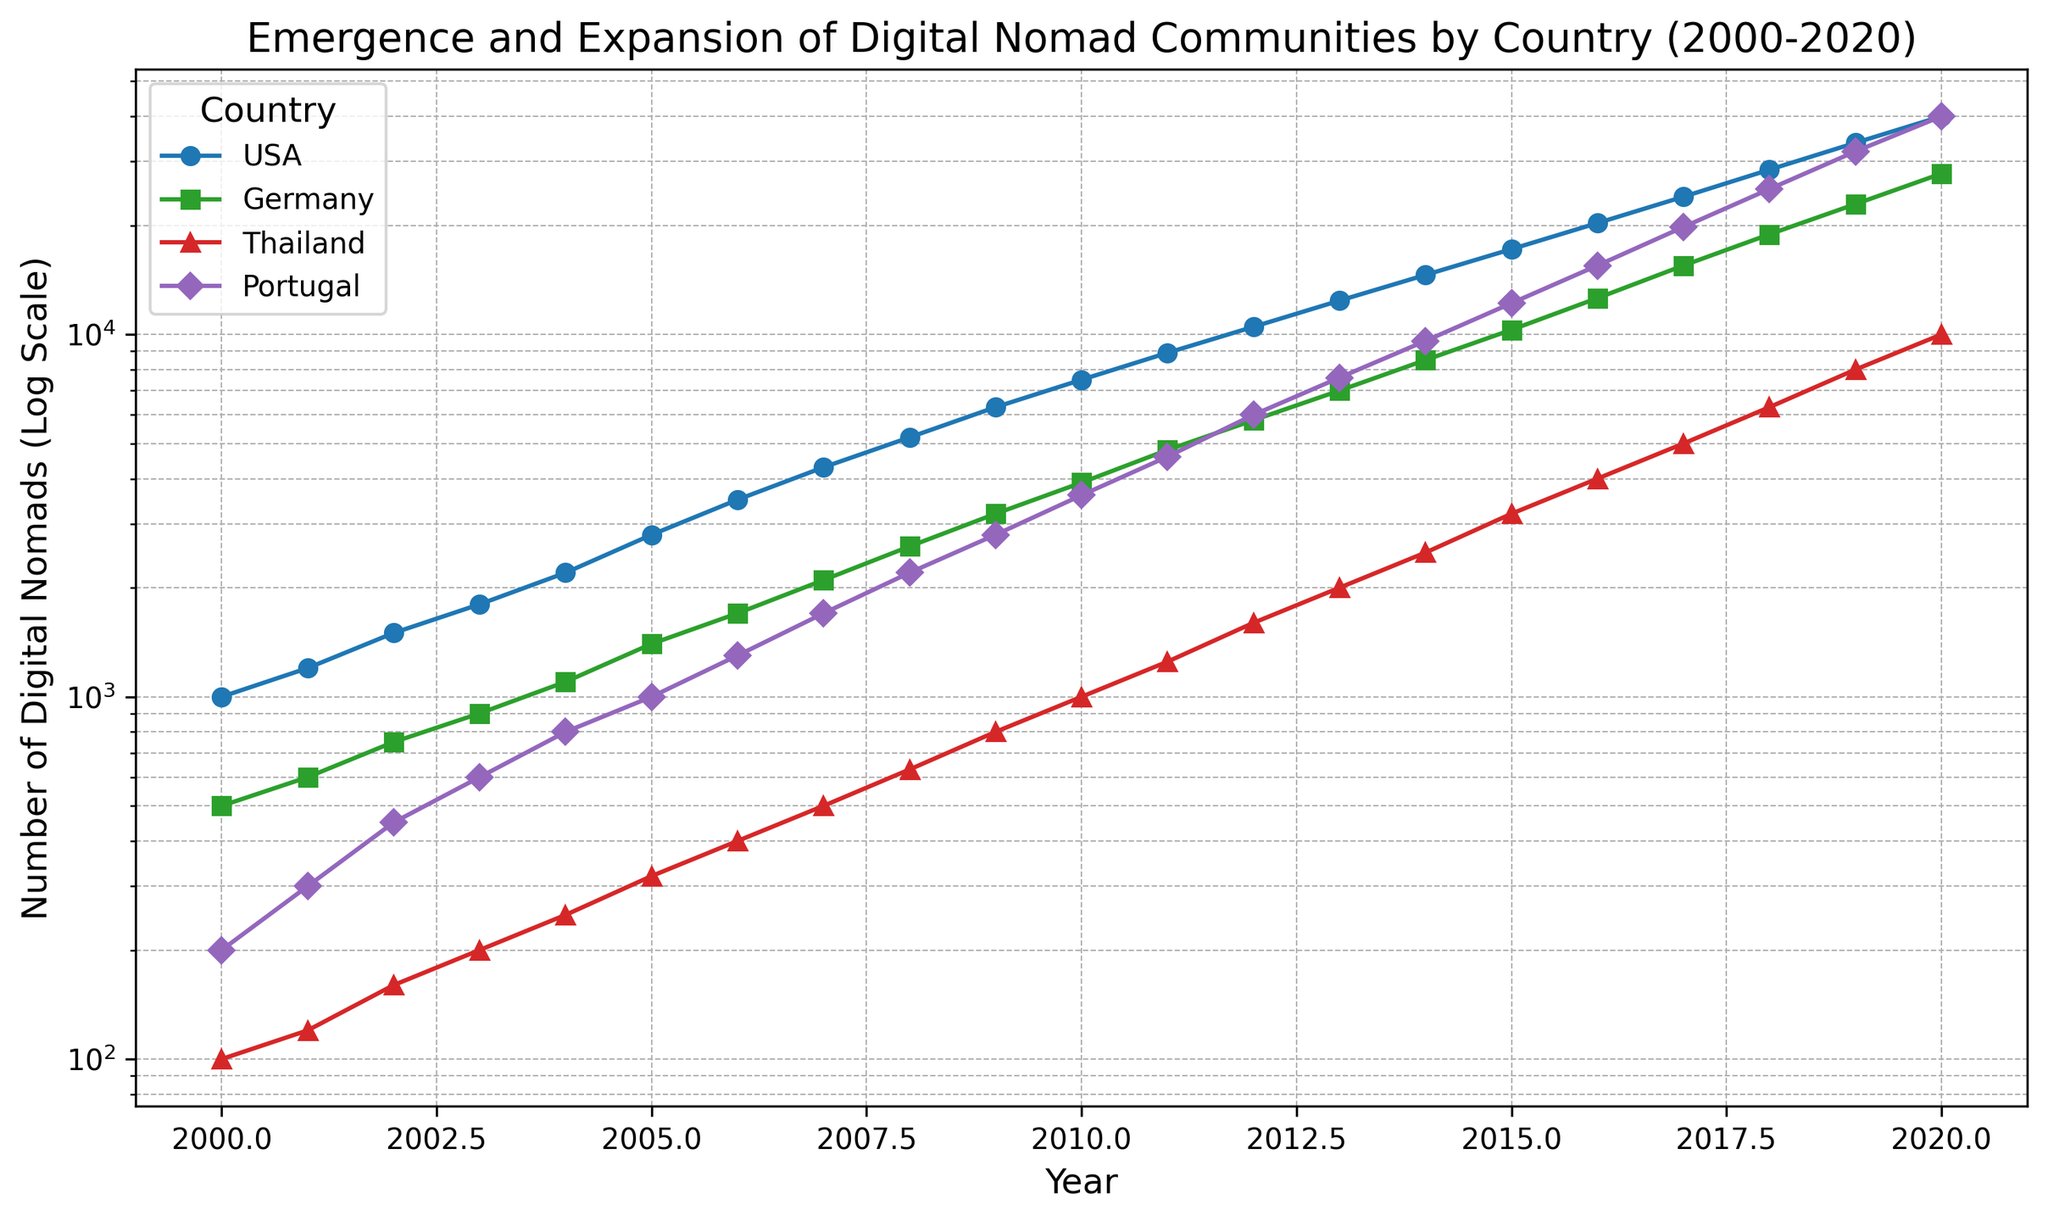Which country had the highest number of digital nomads in 2019? By looking at the 2019 data points for each country, USA has about 33,800, Thailand has 8,000, Germany has 22,900, and Portugal has 32,000. The USA's number is the highest.
Answer: USA What is the ratio of digital nomads in Thailand to those in Germany in 2010? Referring to the 2010 data points, Thailand has 1,000 and Germany has 3,900 digital nomads. The ratio is 1,000 divided by 3,900.
Answer: 1:3.9 Which country had the fastest growth in digital nomads from 2015 to 2020? By inspecting the slope of the lines between 2015 and 2020, Portugal's line shows the steepest increase, indicating the fastest growth compared to USA, Germany, and Thailand.
Answer: Portugal In which year did Germany surpass 10,000 digital nomads? Observing Germany's data points, it surpasses 10,000 in 2015.
Answer: 2015 How does the number of digital nomads in the USA in 2005 compare to that in Thailand in 2020? In 2005, the USA has about 2,800 digital nomads while Thailand in 2020 has about 10,000. Consequently, the number in Thailand in 2020 is significantly higher.
Answer: Thailand has more Which country showed a doubling in the number of digital nomads the quickest? Reviewing the data, Thailand doubles multiple times (e.g., from 1250 in 2011 to 2500 in 2014), which appears to be the quickest compared to other countries like USA, Germany, and Portugal.
Answer: Thailand If you sum the number of digital nomads in all the countries in 2020, what is the total? Summing the 2020 data points for USA (40,000), Germany (27,800), Thailand (10,000), and Portugal (40,000) gives 40,000 + 27,800 + 10,000 + 40,000.
Answer: 117,800 What is the trend in the number of digital nomads in Portugal from 2000 to 2020? Viewing the plotted data points for Portugal, the number steadily increases in an exponential manner from 2000 to 2020, reaching 40,000 in 2020.
Answer: Increasing exponentially Which country had the smallest number of digital nomads in 2008? Looking at the 2008 data points, Thailand has 630 digital nomads, which is the smallest compared to USA, Germany, and Portugal.
Answer: Thailand How did the number of digital nomads in the USA change from 2000 to 2020, and how does this compare to Germany's change over the same period? For the USA, the digital nomads increased from 1,000 in 2000 to 40,000 in 2020 (a 39,000 increase). In Germany, they increased from 500 in 2000 to 27,800 in 2020 (a 27,300 increase). Therefore, the USA had a more substantial increase.
Answer: USA had a larger increase 